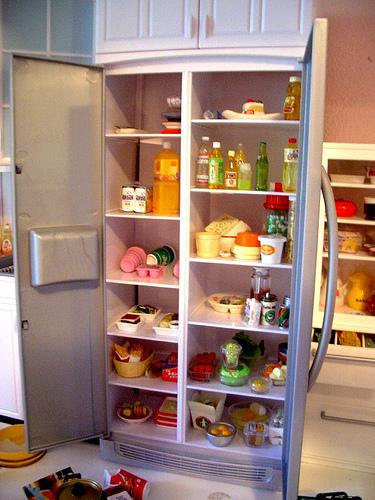What color are the cups in the left side of the fridge?
Answer briefly. Pink. Which shelf has several bottles?
Short answer required. 4th. How many doors on the refrigerator?
Give a very brief answer. 2. 